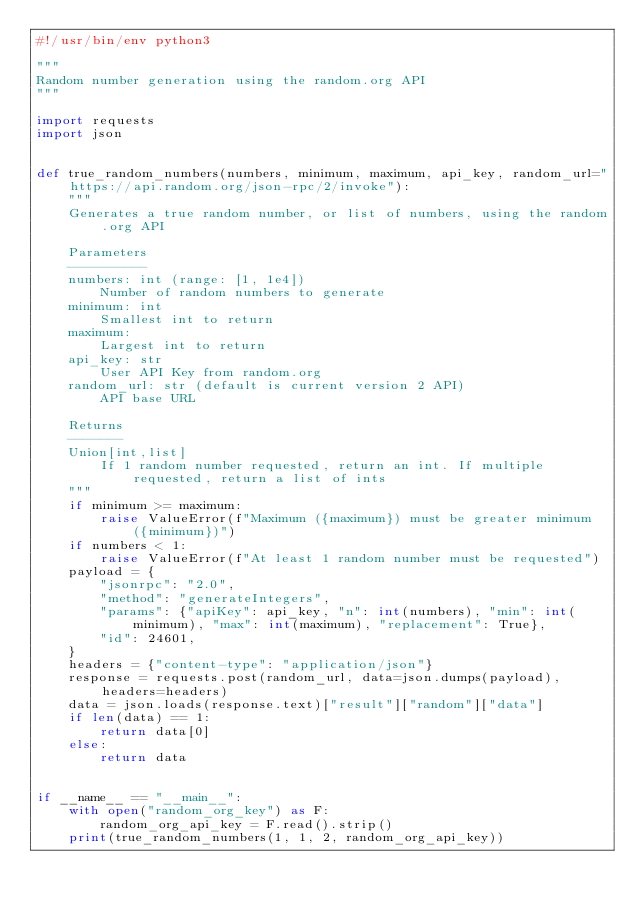Convert code to text. <code><loc_0><loc_0><loc_500><loc_500><_Python_>#!/usr/bin/env python3

"""
Random number generation using the random.org API
"""

import requests
import json


def true_random_numbers(numbers, minimum, maximum, api_key, random_url="https://api.random.org/json-rpc/2/invoke"):
    """
    Generates a true random number, or list of numbers, using the random.org API

    Parameters
    ----------
    numbers: int (range: [1, 1e4])
        Number of random numbers to generate
    minimum: int
        Smallest int to return
    maximum:
        Largest int to return
    api_key: str
        User API Key from random.org
    random_url: str (default is current version 2 API)
        API base URL

    Returns
    -------
    Union[int,list]
        If 1 random number requested, return an int. If multiple requested, return a list of ints
    """
    if minimum >= maximum:
        raise ValueError(f"Maximum ({maximum}) must be greater minimum ({minimum})")
    if numbers < 1:
        raise ValueError(f"At least 1 random number must be requested")
    payload = {
        "jsonrpc": "2.0",
        "method": "generateIntegers",
        "params": {"apiKey": api_key, "n": int(numbers), "min": int(minimum), "max": int(maximum), "replacement": True},
        "id": 24601,
    }
    headers = {"content-type": "application/json"}
    response = requests.post(random_url, data=json.dumps(payload), headers=headers)
    data = json.loads(response.text)["result"]["random"]["data"]
    if len(data) == 1:
        return data[0]
    else:
        return data


if __name__ == "__main__":
    with open("random_org_key") as F:
        random_org_api_key = F.read().strip()
    print(true_random_numbers(1, 1, 2, random_org_api_key))
</code> 